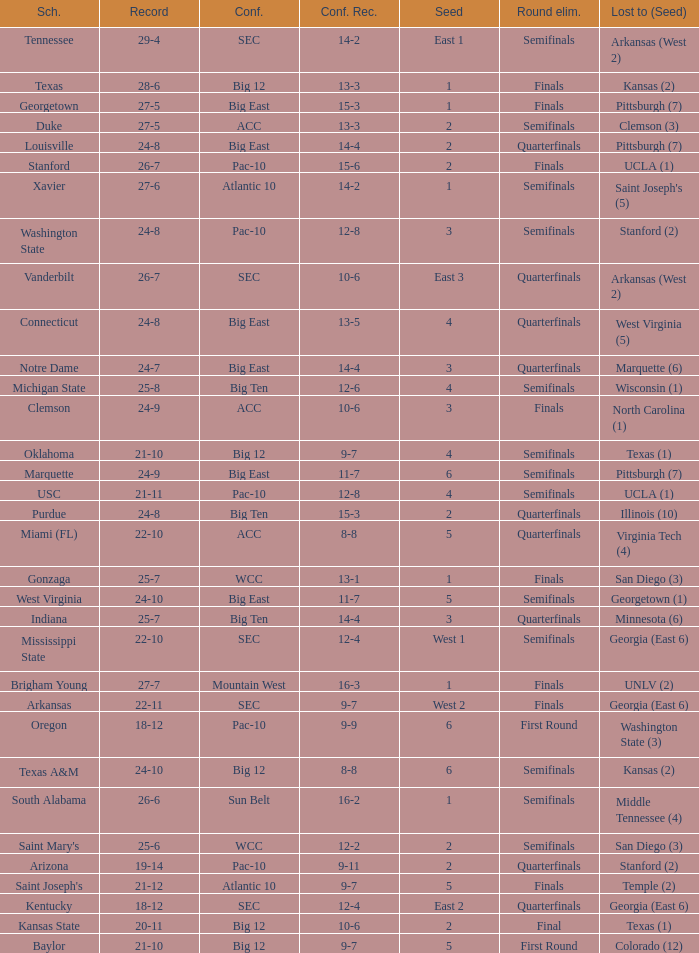Help me parse the entirety of this table. {'header': ['Sch.', 'Record', 'Conf.', 'Conf. Rec.', 'Seed', 'Round elim.', 'Lost to (Seed)'], 'rows': [['Tennessee', '29-4', 'SEC', '14-2', 'East 1', 'Semifinals', 'Arkansas (West 2)'], ['Texas', '28-6', 'Big 12', '13-3', '1', 'Finals', 'Kansas (2)'], ['Georgetown', '27-5', 'Big East', '15-3', '1', 'Finals', 'Pittsburgh (7)'], ['Duke', '27-5', 'ACC', '13-3', '2', 'Semifinals', 'Clemson (3)'], ['Louisville', '24-8', 'Big East', '14-4', '2', 'Quarterfinals', 'Pittsburgh (7)'], ['Stanford', '26-7', 'Pac-10', '15-6', '2', 'Finals', 'UCLA (1)'], ['Xavier', '27-6', 'Atlantic 10', '14-2', '1', 'Semifinals', "Saint Joseph's (5)"], ['Washington State', '24-8', 'Pac-10', '12-8', '3', 'Semifinals', 'Stanford (2)'], ['Vanderbilt', '26-7', 'SEC', '10-6', 'East 3', 'Quarterfinals', 'Arkansas (West 2)'], ['Connecticut', '24-8', 'Big East', '13-5', '4', 'Quarterfinals', 'West Virginia (5)'], ['Notre Dame', '24-7', 'Big East', '14-4', '3', 'Quarterfinals', 'Marquette (6)'], ['Michigan State', '25-8', 'Big Ten', '12-6', '4', 'Semifinals', 'Wisconsin (1)'], ['Clemson', '24-9', 'ACC', '10-6', '3', 'Finals', 'North Carolina (1)'], ['Oklahoma', '21-10', 'Big 12', '9-7', '4', 'Semifinals', 'Texas (1)'], ['Marquette', '24-9', 'Big East', '11-7', '6', 'Semifinals', 'Pittsburgh (7)'], ['USC', '21-11', 'Pac-10', '12-8', '4', 'Semifinals', 'UCLA (1)'], ['Purdue', '24-8', 'Big Ten', '15-3', '2', 'Quarterfinals', 'Illinois (10)'], ['Miami (FL)', '22-10', 'ACC', '8-8', '5', 'Quarterfinals', 'Virginia Tech (4)'], ['Gonzaga', '25-7', 'WCC', '13-1', '1', 'Finals', 'San Diego (3)'], ['West Virginia', '24-10', 'Big East', '11-7', '5', 'Semifinals', 'Georgetown (1)'], ['Indiana', '25-7', 'Big Ten', '14-4', '3', 'Quarterfinals', 'Minnesota (6)'], ['Mississippi State', '22-10', 'SEC', '12-4', 'West 1', 'Semifinals', 'Georgia (East 6)'], ['Brigham Young', '27-7', 'Mountain West', '16-3', '1', 'Finals', 'UNLV (2)'], ['Arkansas', '22-11', 'SEC', '9-7', 'West 2', 'Finals', 'Georgia (East 6)'], ['Oregon', '18-12', 'Pac-10', '9-9', '6', 'First Round', 'Washington State (3)'], ['Texas A&M', '24-10', 'Big 12', '8-8', '6', 'Semifinals', 'Kansas (2)'], ['South Alabama', '26-6', 'Sun Belt', '16-2', '1', 'Semifinals', 'Middle Tennessee (4)'], ["Saint Mary's", '25-6', 'WCC', '12-2', '2', 'Semifinals', 'San Diego (3)'], ['Arizona', '19-14', 'Pac-10', '9-11', '2', 'Quarterfinals', 'Stanford (2)'], ["Saint Joseph's", '21-12', 'Atlantic 10', '9-7', '5', 'Finals', 'Temple (2)'], ['Kentucky', '18-12', 'SEC', '12-4', 'East 2', 'Quarterfinals', 'Georgia (East 6)'], ['Kansas State', '20-11', 'Big 12', '10-6', '2', 'Final', 'Texas (1)'], ['Baylor', '21-10', 'Big 12', '9-7', '5', 'First Round', 'Colorado (12)']]} Which school boasts a conference record of 12 wins and 6 losses? Michigan State. 